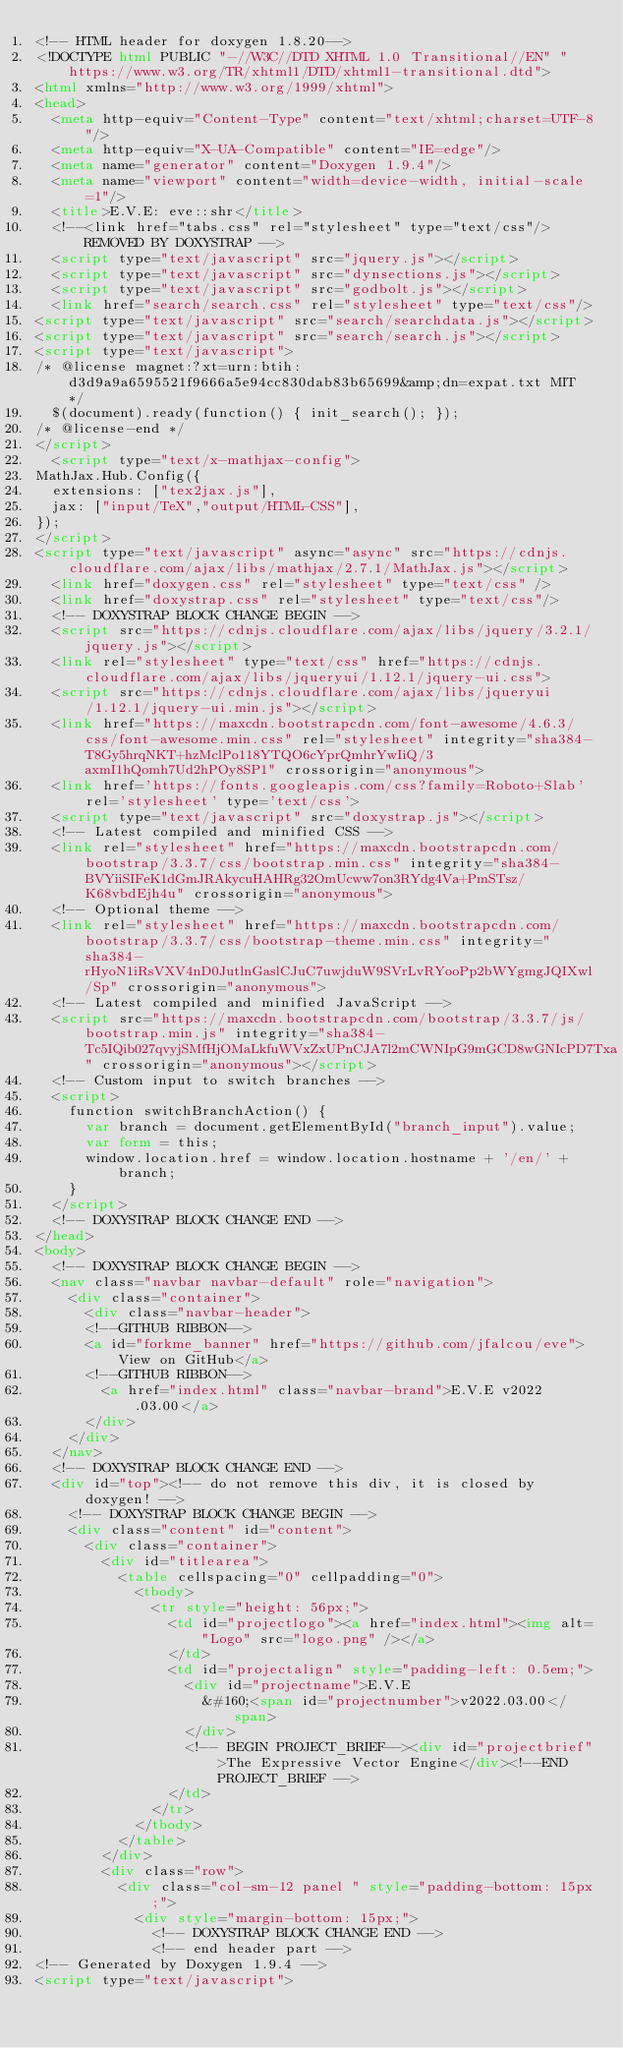<code> <loc_0><loc_0><loc_500><loc_500><_HTML_><!-- HTML header for doxygen 1.8.20-->
<!DOCTYPE html PUBLIC "-//W3C//DTD XHTML 1.0 Transitional//EN" "https://www.w3.org/TR/xhtml1/DTD/xhtml1-transitional.dtd">
<html xmlns="http://www.w3.org/1999/xhtml">
<head>
  <meta http-equiv="Content-Type" content="text/xhtml;charset=UTF-8"/>
  <meta http-equiv="X-UA-Compatible" content="IE=edge"/>
  <meta name="generator" content="Doxygen 1.9.4"/>
  <meta name="viewport" content="width=device-width, initial-scale=1"/>
  <title>E.V.E: eve::shr</title>
  <!--<link href="tabs.css" rel="stylesheet" type="text/css"/> REMOVED BY DOXYSTRAP -->
  <script type="text/javascript" src="jquery.js"></script>
  <script type="text/javascript" src="dynsections.js"></script>
  <script type="text/javascript" src="godbolt.js"></script>
  <link href="search/search.css" rel="stylesheet" type="text/css"/>
<script type="text/javascript" src="search/searchdata.js"></script>
<script type="text/javascript" src="search/search.js"></script>
<script type="text/javascript">
/* @license magnet:?xt=urn:btih:d3d9a9a6595521f9666a5e94cc830dab83b65699&amp;dn=expat.txt MIT */
  $(document).ready(function() { init_search(); });
/* @license-end */
</script>
  <script type="text/x-mathjax-config">
MathJax.Hub.Config({
  extensions: ["tex2jax.js"],
  jax: ["input/TeX","output/HTML-CSS"],
});
</script>
<script type="text/javascript" async="async" src="https://cdnjs.cloudflare.com/ajax/libs/mathjax/2.7.1/MathJax.js"></script>
  <link href="doxygen.css" rel="stylesheet" type="text/css" />
  <link href="doxystrap.css" rel="stylesheet" type="text/css"/>
  <!-- DOXYSTRAP BLOCK CHANGE BEGIN -->
  <script src="https://cdnjs.cloudflare.com/ajax/libs/jquery/3.2.1/jquery.js"></script>
  <link rel="stylesheet" type="text/css" href="https://cdnjs.cloudflare.com/ajax/libs/jqueryui/1.12.1/jquery-ui.css">
  <script src="https://cdnjs.cloudflare.com/ajax/libs/jqueryui/1.12.1/jquery-ui.min.js"></script>
  <link href="https://maxcdn.bootstrapcdn.com/font-awesome/4.6.3/css/font-awesome.min.css" rel="stylesheet" integrity="sha384-T8Gy5hrqNKT+hzMclPo118YTQO6cYprQmhrYwIiQ/3axmI1hQomh7Ud2hPOy8SP1" crossorigin="anonymous">
  <link href='https://fonts.googleapis.com/css?family=Roboto+Slab' rel='stylesheet' type='text/css'>
  <script type="text/javascript" src="doxystrap.js"></script>
  <!-- Latest compiled and minified CSS -->
  <link rel="stylesheet" href="https://maxcdn.bootstrapcdn.com/bootstrap/3.3.7/css/bootstrap.min.css" integrity="sha384-BVYiiSIFeK1dGmJRAkycuHAHRg32OmUcww7on3RYdg4Va+PmSTsz/K68vbdEjh4u" crossorigin="anonymous">
  <!-- Optional theme -->
  <link rel="stylesheet" href="https://maxcdn.bootstrapcdn.com/bootstrap/3.3.7/css/bootstrap-theme.min.css" integrity="sha384-rHyoN1iRsVXV4nD0JutlnGaslCJuC7uwjduW9SVrLvRYooPp2bWYgmgJQIXwl/Sp" crossorigin="anonymous">
  <!-- Latest compiled and minified JavaScript -->
  <script src="https://maxcdn.bootstrapcdn.com/bootstrap/3.3.7/js/bootstrap.min.js" integrity="sha384-Tc5IQib027qvyjSMfHjOMaLkfuWVxZxUPnCJA7l2mCWNIpG9mGCD8wGNIcPD7Txa" crossorigin="anonymous"></script>
  <!-- Custom input to switch branches -->
  <script>
    function switchBranchAction() {
      var branch = document.getElementById("branch_input").value;
      var form = this;
      window.location.href = window.location.hostname + '/en/' + branch;
    }
  </script>
  <!-- DOXYSTRAP BLOCK CHANGE END -->
</head>
<body>
  <!-- DOXYSTRAP BLOCK CHANGE BEGIN -->
  <nav class="navbar navbar-default" role="navigation">
    <div class="container">
      <div class="navbar-header">
      <!--GITHUB RIBBON-->
      <a id="forkme_banner" href="https://github.com/jfalcou/eve">View on GitHub</a>
      <!--GITHUB RIBBON-->
        <a href="index.html" class="navbar-brand">E.V.E v2022.03.00</a>
      </div>
    </div>
  </nav>
  <!-- DOXYSTRAP BLOCK CHANGE END -->
  <div id="top"><!-- do not remove this div, it is closed by doxygen! -->
    <!-- DOXYSTRAP BLOCK CHANGE BEGIN -->
    <div class="content" id="content">
      <div class="container">
        <div id="titlearea">
          <table cellspacing="0" cellpadding="0">
            <tbody>
              <tr style="height: 56px;">
                <td id="projectlogo"><a href="index.html"><img alt="Logo" src="logo.png" /></a>
                </td>
                <td id="projectalign" style="padding-left: 0.5em;">
                  <div id="projectname">E.V.E
                    &#160;<span id="projectnumber">v2022.03.00</span>
                  </div>
                  <!-- BEGIN PROJECT_BRIEF--><div id="projectbrief">The Expressive Vector Engine</div><!--END PROJECT_BRIEF -->
                </td>
              </tr>
            </tbody>
          </table>
        </div>
        <div class="row">
          <div class="col-sm-12 panel " style="padding-bottom: 15px;">
            <div style="margin-bottom: 15px;">
              <!-- DOXYSTRAP BLOCK CHANGE END -->
              <!-- end header part -->
<!-- Generated by Doxygen 1.9.4 -->
<script type="text/javascript"></code> 